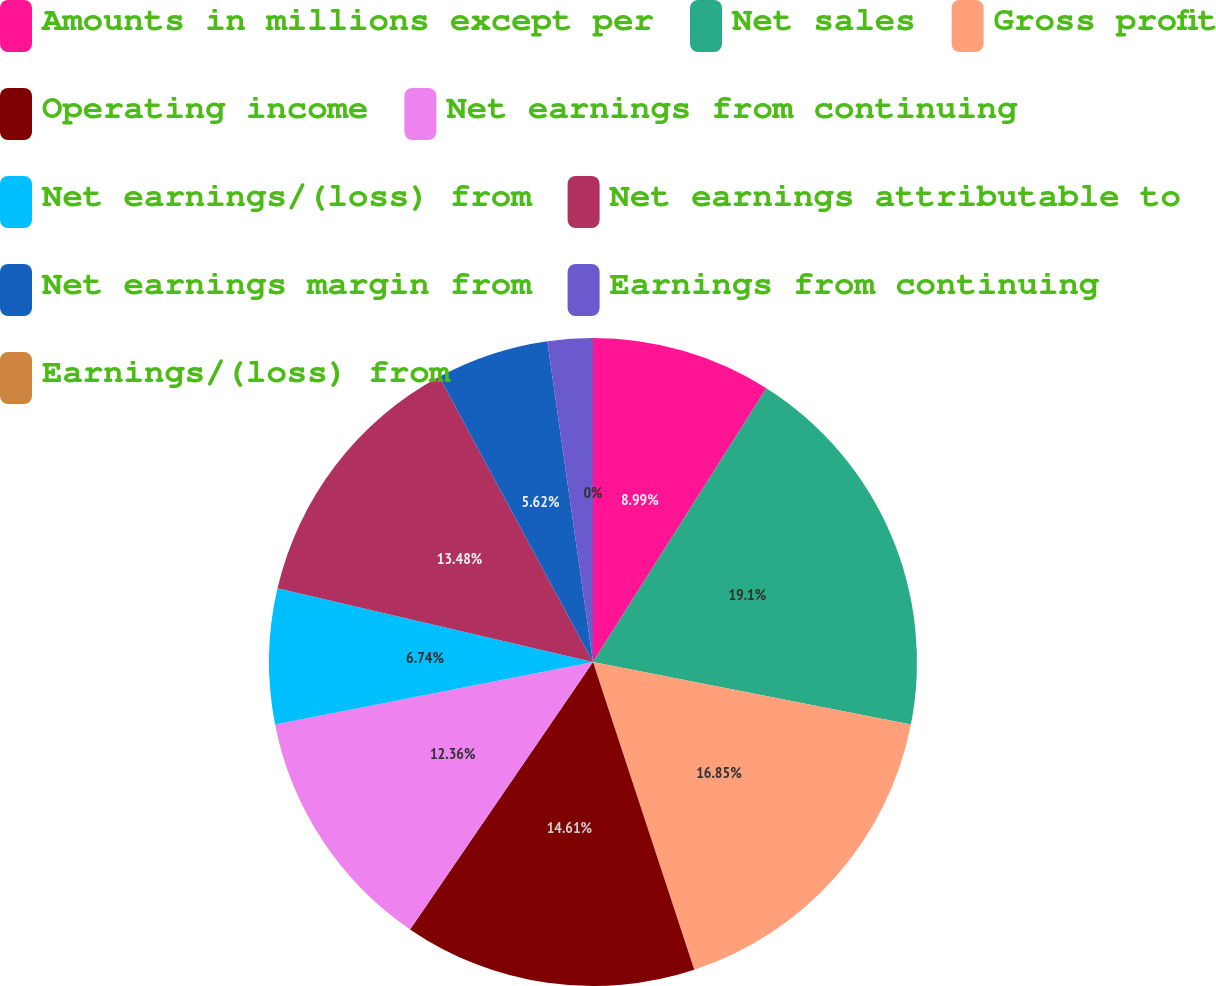Convert chart. <chart><loc_0><loc_0><loc_500><loc_500><pie_chart><fcel>Amounts in millions except per<fcel>Net sales<fcel>Gross profit<fcel>Operating income<fcel>Net earnings from continuing<fcel>Net earnings/(loss) from<fcel>Net earnings attributable to<fcel>Net earnings margin from<fcel>Earnings from continuing<fcel>Earnings/(loss) from<nl><fcel>8.99%<fcel>19.1%<fcel>16.85%<fcel>14.61%<fcel>12.36%<fcel>6.74%<fcel>13.48%<fcel>5.62%<fcel>2.25%<fcel>0.0%<nl></chart> 